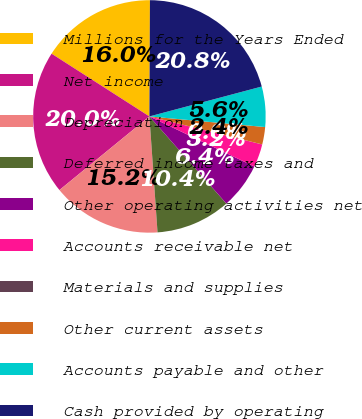<chart> <loc_0><loc_0><loc_500><loc_500><pie_chart><fcel>Millions for the Years Ended<fcel>Net income<fcel>Depreciation<fcel>Deferred income taxes and<fcel>Other operating activities net<fcel>Accounts receivable net<fcel>Materials and supplies<fcel>Other current assets<fcel>Accounts payable and other<fcel>Cash provided by operating<nl><fcel>16.0%<fcel>19.99%<fcel>15.2%<fcel>10.4%<fcel>6.4%<fcel>3.21%<fcel>0.01%<fcel>2.41%<fcel>5.6%<fcel>20.79%<nl></chart> 